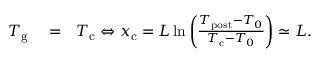<formula> <loc_0><loc_0><loc_500><loc_500>\begin{array} { r l r } { T _ { g } } & = } & { T _ { c } \Leftrightarrow x _ { c } = L \ln \left ( \frac { T _ { p o s t } - T _ { 0 } } { T _ { c } - T _ { 0 } } \right ) \simeq L . } \end{array}</formula> 